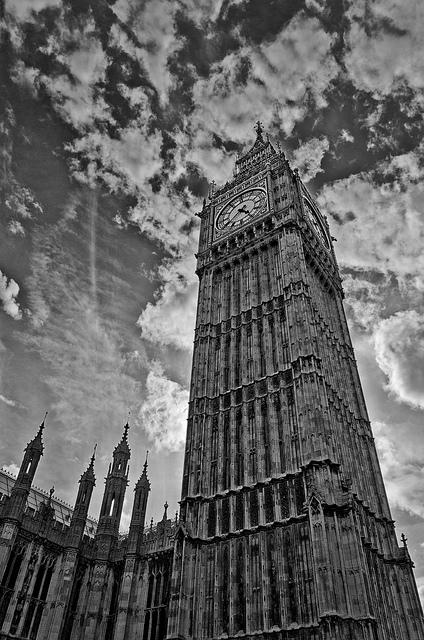What time is it?
Give a very brief answer. 5:25. Do the rooftops have points?
Give a very brief answer. Yes. Where is this located?
Give a very brief answer. London. 